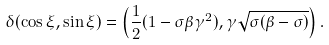<formula> <loc_0><loc_0><loc_500><loc_500>\delta ( \cos { \xi } , \sin { \xi } ) = \left ( \frac { 1 } { 2 } ( 1 - \sigma \beta \gamma ^ { 2 } ) , \gamma \sqrt { \sigma ( \beta - \sigma ) } \right ) .</formula> 